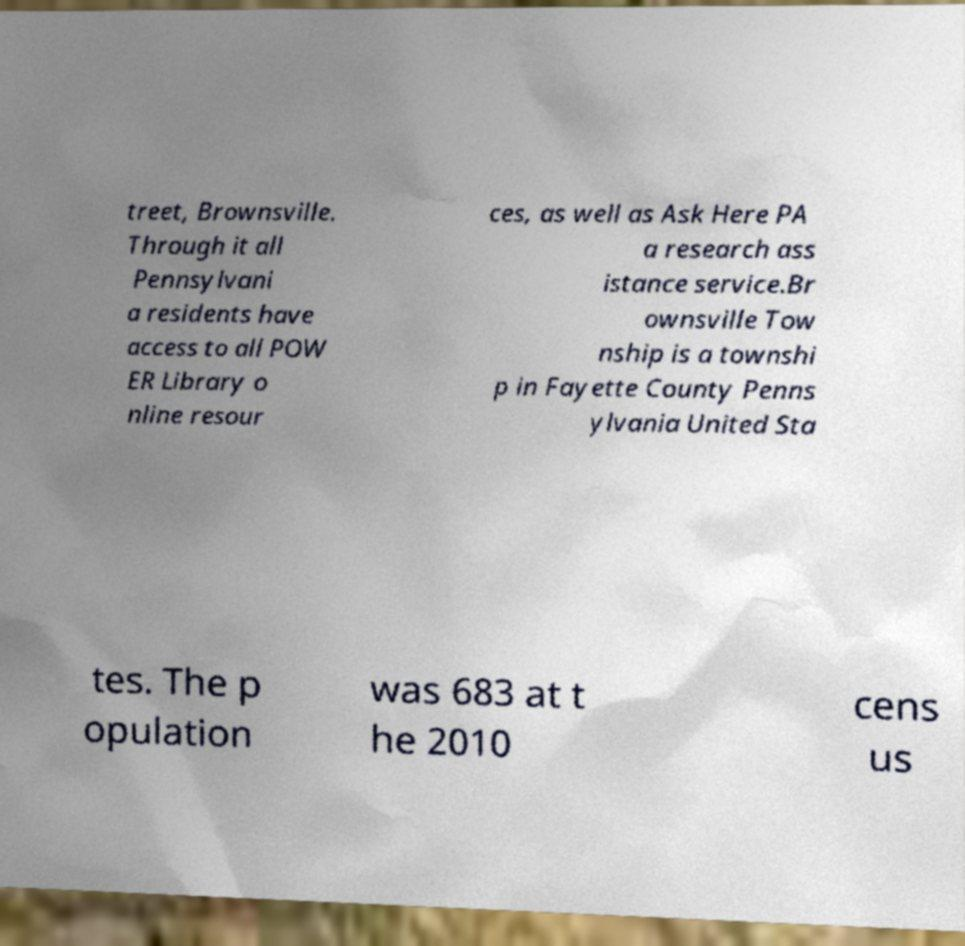What messages or text are displayed in this image? I need them in a readable, typed format. treet, Brownsville. Through it all Pennsylvani a residents have access to all POW ER Library o nline resour ces, as well as Ask Here PA a research ass istance service.Br ownsville Tow nship is a townshi p in Fayette County Penns ylvania United Sta tes. The p opulation was 683 at t he 2010 cens us 